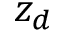Convert formula to latex. <formula><loc_0><loc_0><loc_500><loc_500>z _ { d }</formula> 